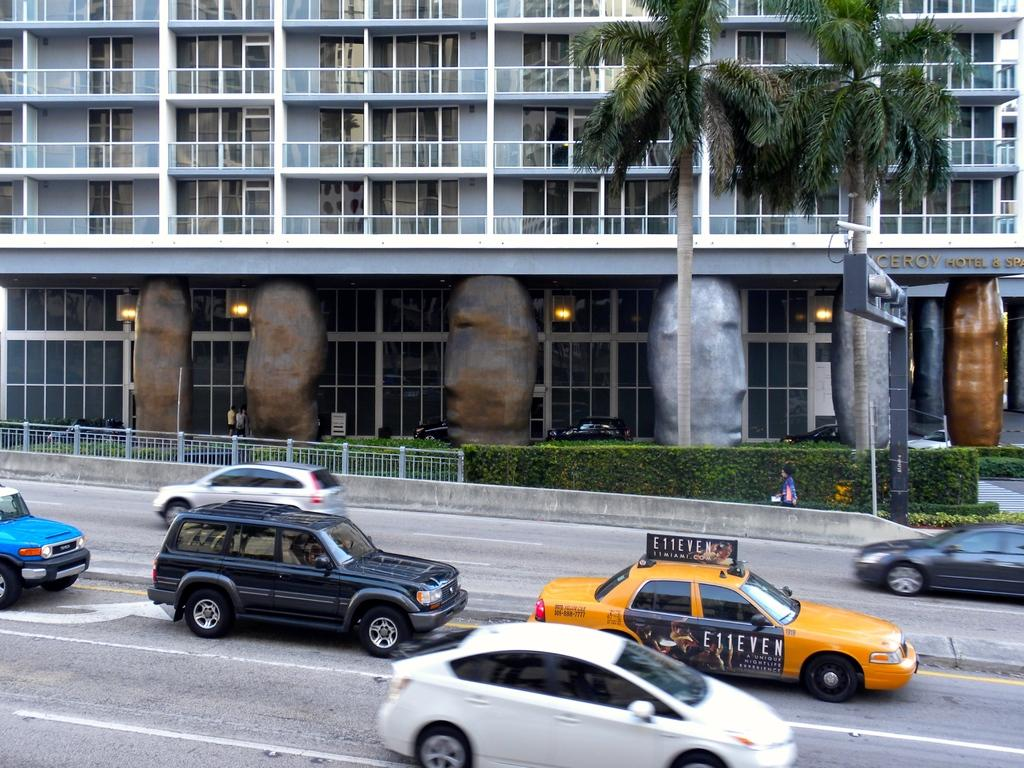<image>
Write a terse but informative summary of the picture. A taxi cab bears an advertisement for E11even: a unique nightlife experience. 